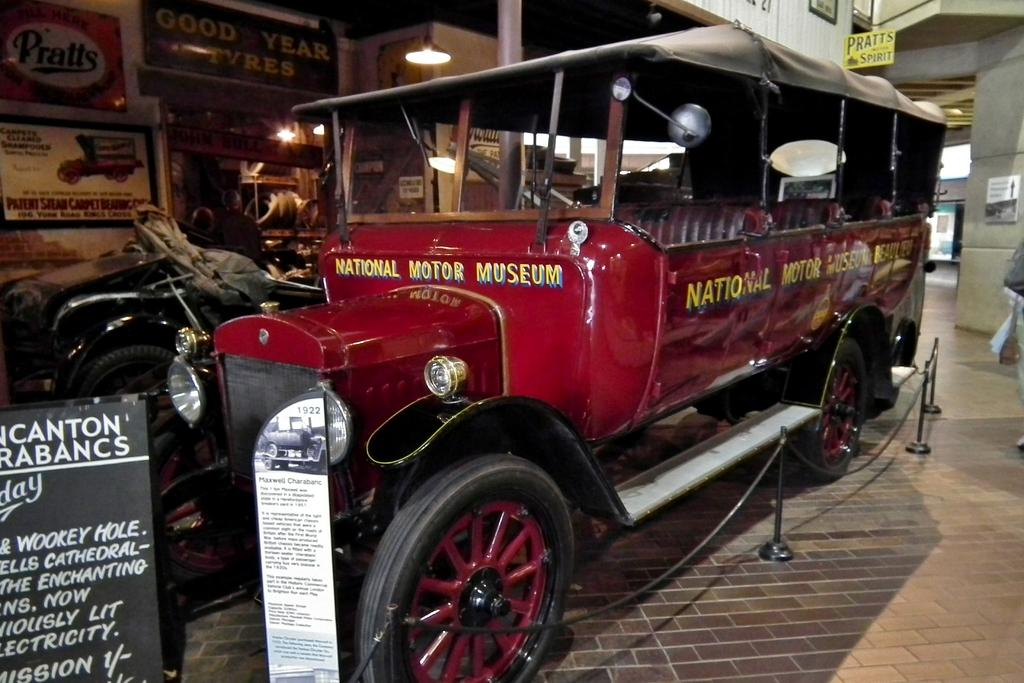What can be seen on the surface in the image? There are vehicles on the surface in the image. What is placed in front of the vehicles? There are boards in front of the vehicles. What can be seen in the background of the image? There are boards and light visible in the background of the image, as well as a wall. How many cattle are participating in the competition in the image? There are no cattle or competition present in the image. What is the height from which the object was dropped in the image? There is no object being dropped in the image. 